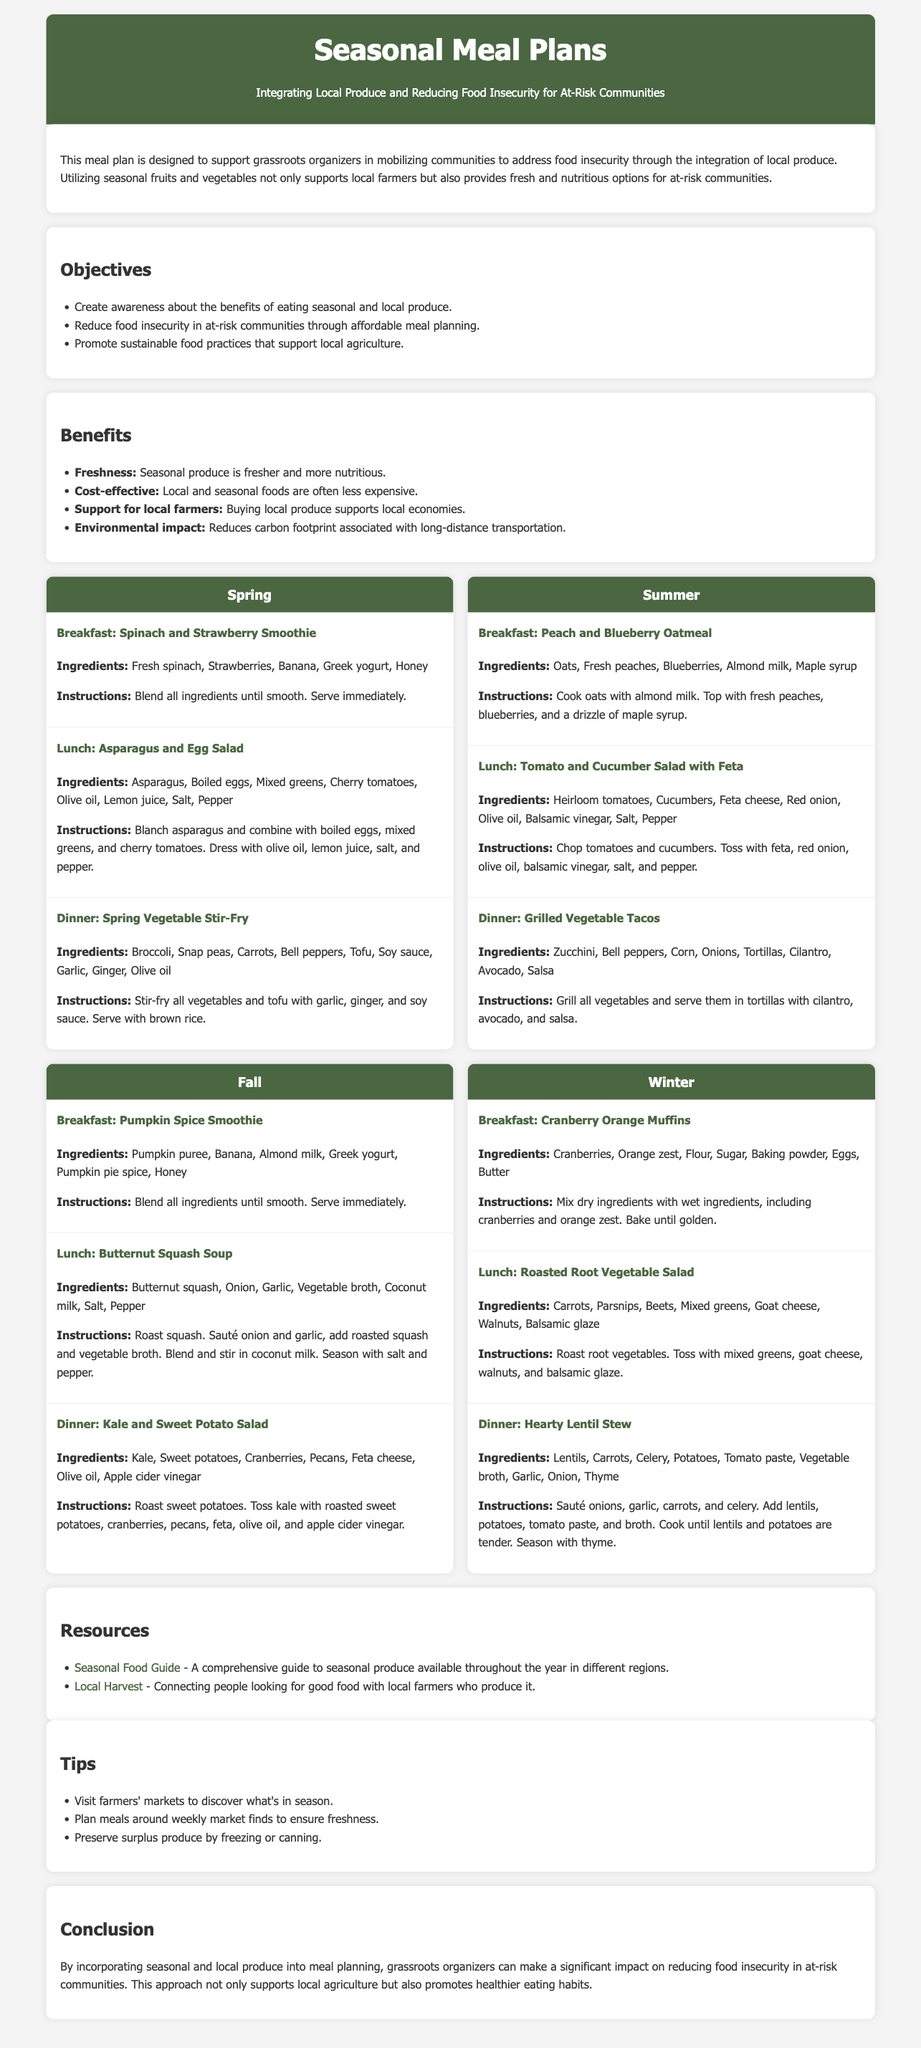what is the title of the document? The title is located in the header section of the document, which states "Seasonal Meal Plans".
Answer: Seasonal Meal Plans how many seasons are covered in the meal plans? The document includes meal plans for four distinct seasons: Spring, Summer, Fall, and Winter.
Answer: Four what is one objective of the meal plan? Objectives are listed in a section, and one of them is "Create awareness about the benefits of eating seasonal and local produce."
Answer: Create awareness about the benefits of eating seasonal and local produce which meal is suggested for breakfast in Fall? The specific breakfast meal for Fall is mentioned and identified as "Pumpkin Spice Smoothie".
Answer: Pumpkin Spice Smoothie name a key benefit of using local produce. The benefits section outlines advantages, one of which is "Support for local farmers."
Answer: Support for local farmers what type of salad is suggested for lunch in Winter? The document clearly states that the lunch option for Winter is "Roasted Root Vegetable Salad."
Answer: Roasted Root Vegetable Salad what is a tip provided for utilizing seasonal produce? The tips section gives recommendations, including visiting farmers' markets to discover seasonal produce.
Answer: Visit farmers' markets to discover what's in season what ingredient is listed in the Hearty Lentil Stew? The dinner recipe for Hearty Lentil Stew includes several ingredients, one of which is "Lentils."
Answer: Lentils 